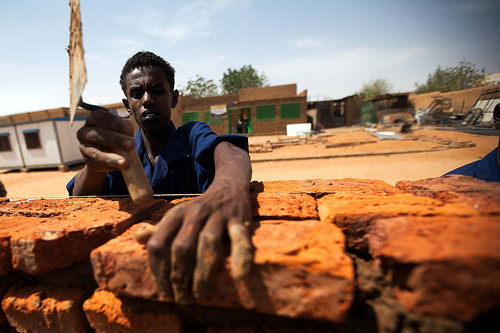<image>
Is the man on the brick? No. The man is not positioned on the brick. They may be near each other, but the man is not supported by or resting on top of the brick. Is there a man under the home? No. The man is not positioned under the home. The vertical relationship between these objects is different. 